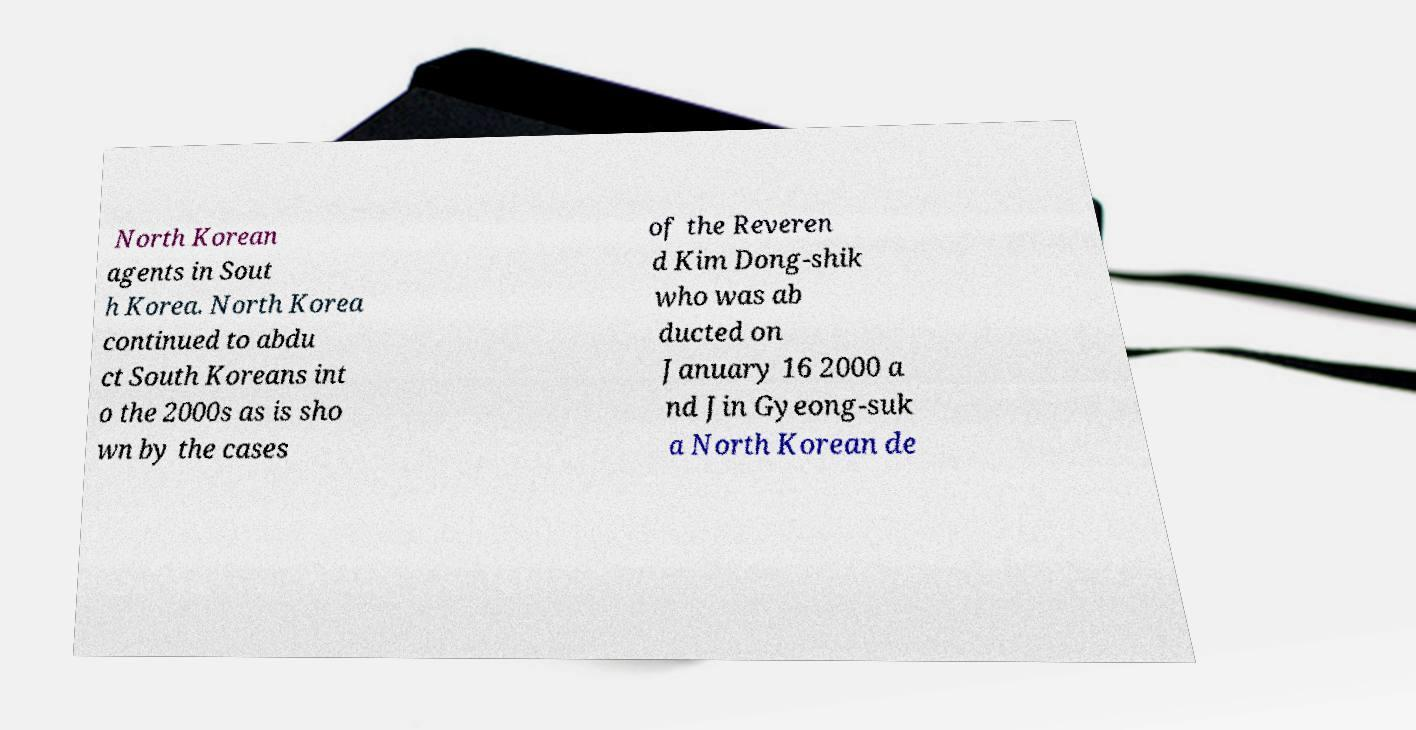There's text embedded in this image that I need extracted. Can you transcribe it verbatim? North Korean agents in Sout h Korea. North Korea continued to abdu ct South Koreans int o the 2000s as is sho wn by the cases of the Reveren d Kim Dong-shik who was ab ducted on January 16 2000 a nd Jin Gyeong-suk a North Korean de 